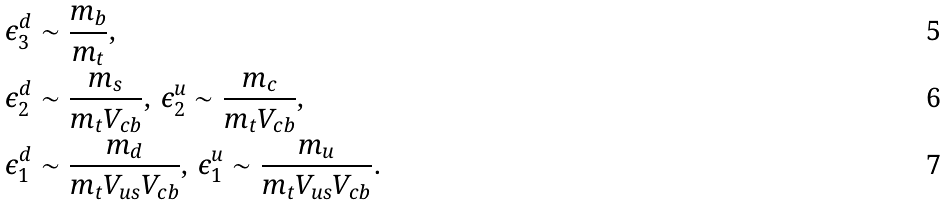Convert formula to latex. <formula><loc_0><loc_0><loc_500><loc_500>\epsilon ^ { d } _ { 3 } & \sim \frac { m _ { b } } { m _ { t } } , \\ \epsilon ^ { d } _ { 2 } & \sim \frac { m _ { s } } { m _ { t } V _ { c b } } , \, \epsilon ^ { u } _ { 2 } \sim \frac { m _ { c } } { m _ { t } V _ { c b } } , \\ \epsilon ^ { d } _ { 1 } & \sim \frac { m _ { d } } { m _ { t } V _ { u s } V _ { c b } } , \, \epsilon ^ { u } _ { 1 } \sim \frac { m _ { u } } { m _ { t } V _ { u s } V _ { c b } } .</formula> 